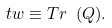<formula> <loc_0><loc_0><loc_500><loc_500>\ t w \equiv T r \ ( Q ) .</formula> 